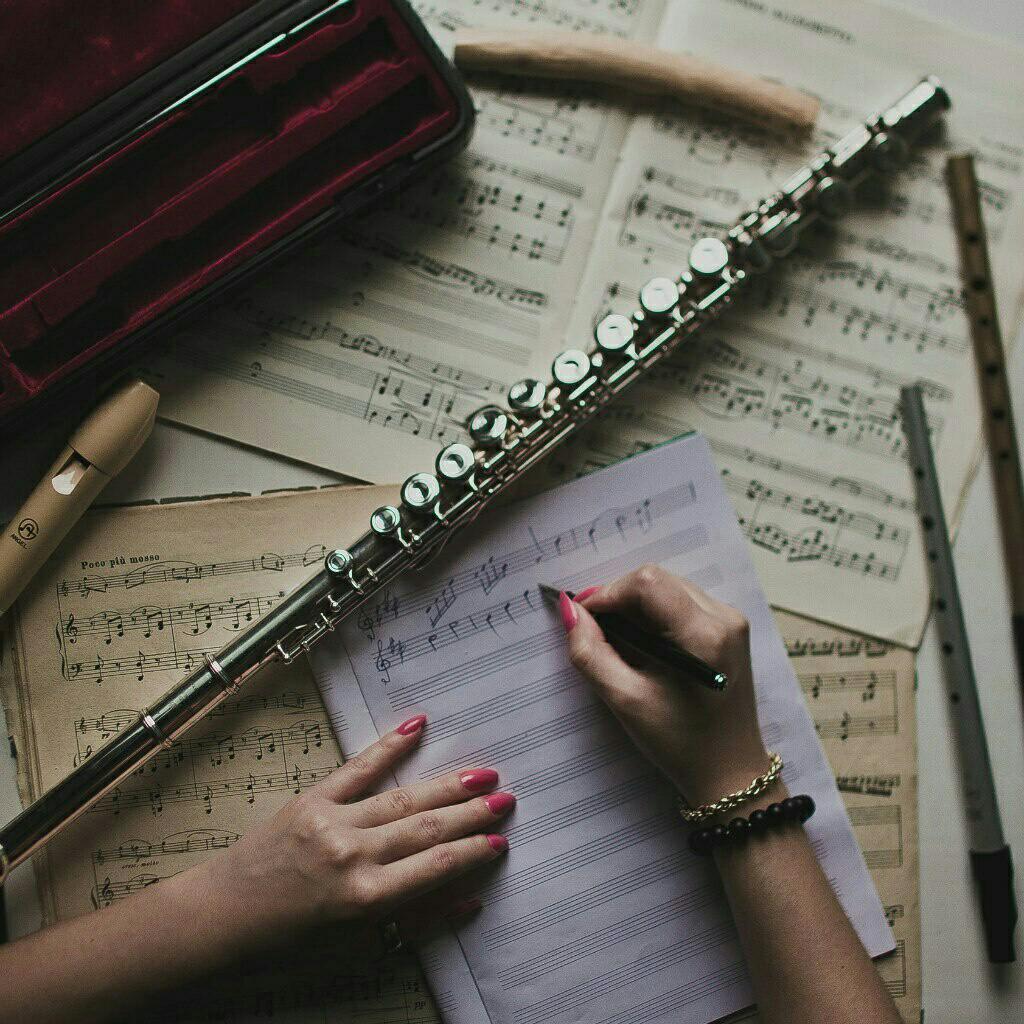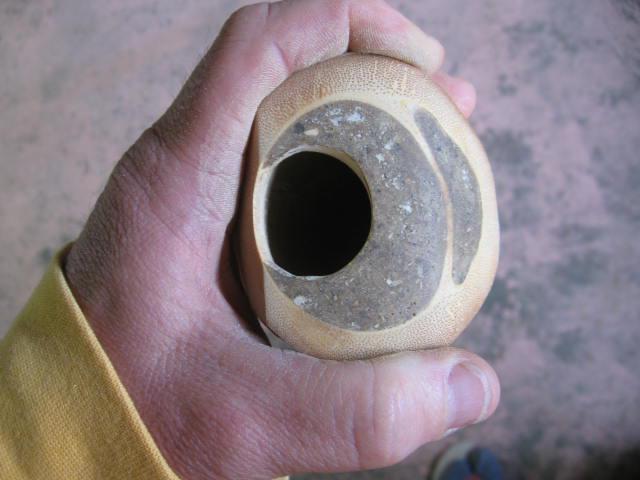The first image is the image on the left, the second image is the image on the right. Evaluate the accuracy of this statement regarding the images: "One image shows three flutes side by side, with their ends closer together at the top of the image.". Is it true? Answer yes or no. No. The first image is the image on the left, the second image is the image on the right. Analyze the images presented: Is the assertion "One of the images contains exactly three flutes." valid? Answer yes or no. No. 